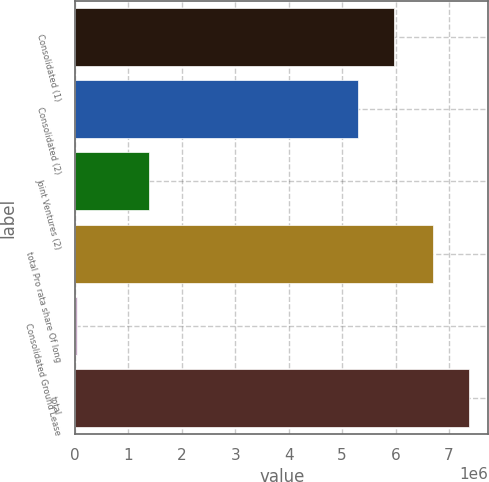Convert chart to OTSL. <chart><loc_0><loc_0><loc_500><loc_500><bar_chart><fcel>Consolidated (1)<fcel>Consolidated (2)<fcel>Joint Ventures (2)<fcel>total Pro rata share Of long<fcel>Consolidated Ground Lease<fcel>total<nl><fcel>5.97891e+06<fcel>5.30435e+06<fcel>1.39166e+06<fcel>6.69601e+06<fcel>32626<fcel>7.37057e+06<nl></chart> 